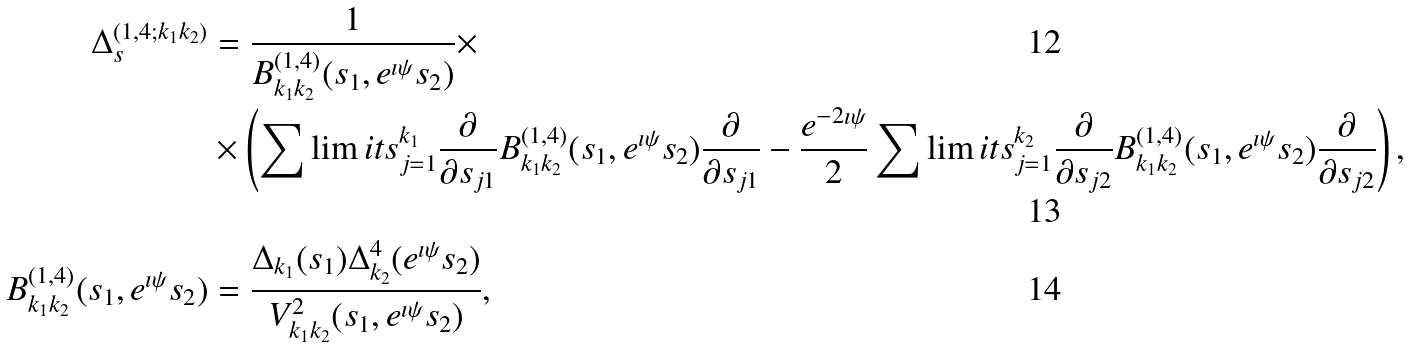Convert formula to latex. <formula><loc_0><loc_0><loc_500><loc_500>\Delta _ { s } ^ { ( 1 , 4 ; k _ { 1 } k _ { 2 } ) } & = \frac { 1 } { B _ { k _ { 1 } k _ { 2 } } ^ { ( 1 , 4 ) } ( s _ { 1 } , e ^ { \imath \psi } s _ { 2 } ) } \times \\ & \times \left ( \sum \lim i t s _ { j = 1 } ^ { k _ { 1 } } \frac { \partial } { \partial s _ { j 1 } } B _ { k _ { 1 } k _ { 2 } } ^ { ( 1 , 4 ) } ( s _ { 1 } , e ^ { \imath \psi } s _ { 2 } ) \frac { \partial } { \partial s _ { j 1 } } - \frac { e ^ { - 2 \imath \psi } } { 2 } \sum \lim i t s _ { j = 1 } ^ { k _ { 2 } } \frac { \partial } { \partial s _ { j 2 } } B _ { k _ { 1 } k _ { 2 } } ^ { ( 1 , 4 ) } ( s _ { 1 } , e ^ { \imath \psi } s _ { 2 } ) \frac { \partial } { \partial s _ { j 2 } } \right ) , \\ B _ { k _ { 1 } k _ { 2 } } ^ { ( 1 , 4 ) } ( s _ { 1 } , e ^ { \imath \psi } s _ { 2 } ) & = \frac { \Delta _ { k _ { 1 } } ( s _ { 1 } ) \Delta _ { k _ { 2 } } ^ { 4 } ( e ^ { \imath \psi } s _ { 2 } ) } { V _ { k _ { 1 } k _ { 2 } } ^ { 2 } ( s _ { 1 } , e ^ { \imath \psi } s _ { 2 } ) } ,</formula> 